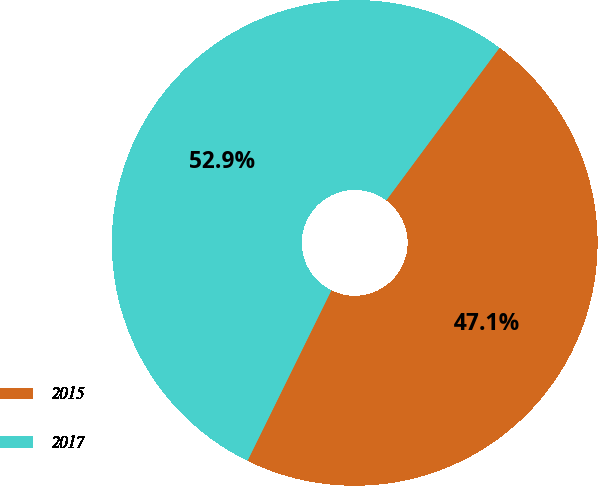Convert chart. <chart><loc_0><loc_0><loc_500><loc_500><pie_chart><fcel>2015<fcel>2017<nl><fcel>47.12%<fcel>52.88%<nl></chart> 